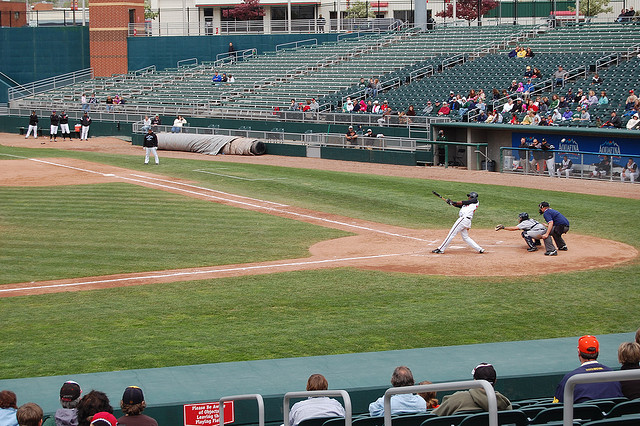<image>Who is winning? It is ambiguous to determine who is winning without the related image. Who is winning? I don't know who is winning. It could be the players, the home team, the away team, the white team, or the other team. 